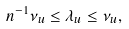<formula> <loc_0><loc_0><loc_500><loc_500>n ^ { - 1 } \nu _ { u } \leq \lambda _ { u } \leq \nu _ { u } ,</formula> 